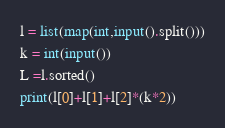<code> <loc_0><loc_0><loc_500><loc_500><_Python_>l = list(map(int,input().split()))
k = int(input())
L =l.sorted()
print(l[0]+l[1]+l[2]*(k*2))
</code> 